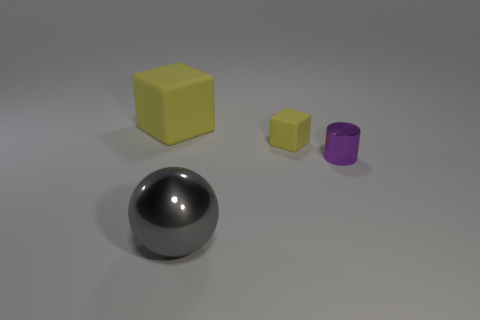Add 3 tiny shiny balls. How many objects exist? 7 Subtract all spheres. How many objects are left? 3 Subtract 0 blue balls. How many objects are left? 4 Subtract all blue shiny cubes. Subtract all gray shiny objects. How many objects are left? 3 Add 2 small purple cylinders. How many small purple cylinders are left? 3 Add 3 small cyan metal balls. How many small cyan metal balls exist? 3 